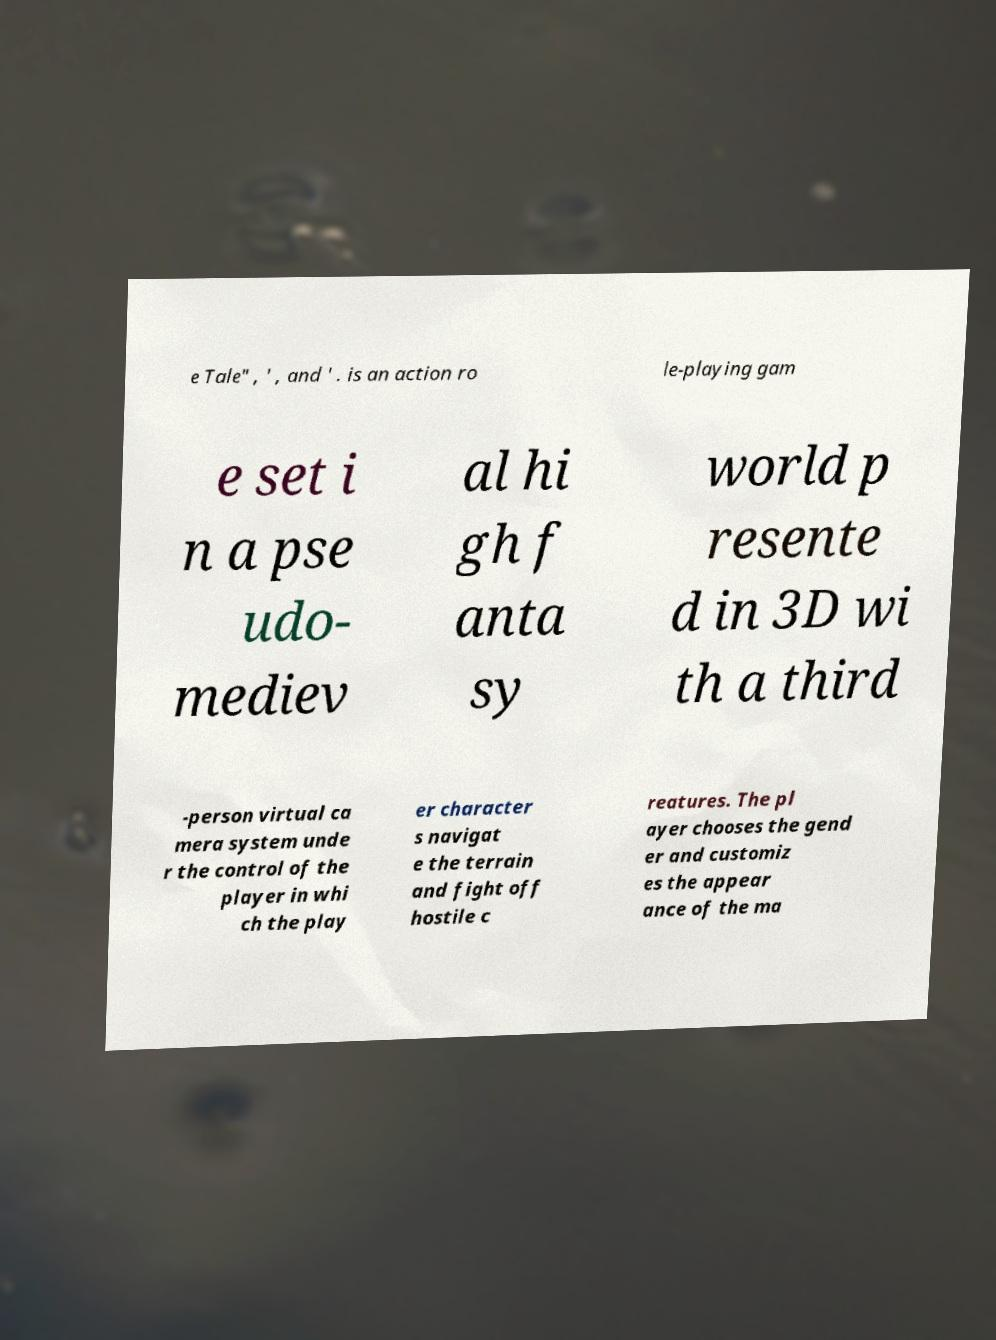Can you read and provide the text displayed in the image?This photo seems to have some interesting text. Can you extract and type it out for me? e Tale" , ' , and ' . is an action ro le-playing gam e set i n a pse udo- mediev al hi gh f anta sy world p resente d in 3D wi th a third -person virtual ca mera system unde r the control of the player in whi ch the play er character s navigat e the terrain and fight off hostile c reatures. The pl ayer chooses the gend er and customiz es the appear ance of the ma 